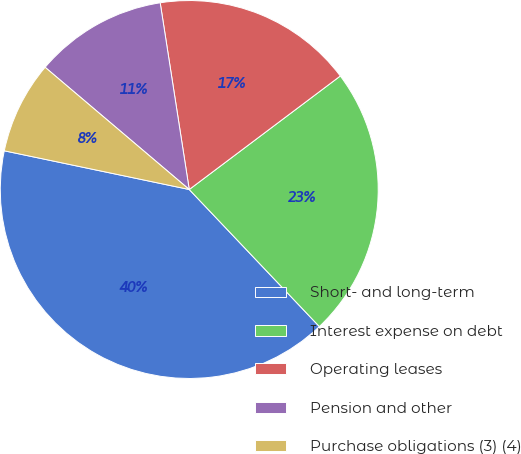<chart> <loc_0><loc_0><loc_500><loc_500><pie_chart><fcel>Short- and long-term<fcel>Interest expense on debt<fcel>Operating leases<fcel>Pension and other<fcel>Purchase obligations (3) (4)<nl><fcel>40.37%<fcel>23.17%<fcel>17.2%<fcel>11.35%<fcel>7.91%<nl></chart> 